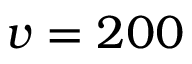<formula> <loc_0><loc_0><loc_500><loc_500>v = 2 0 0</formula> 